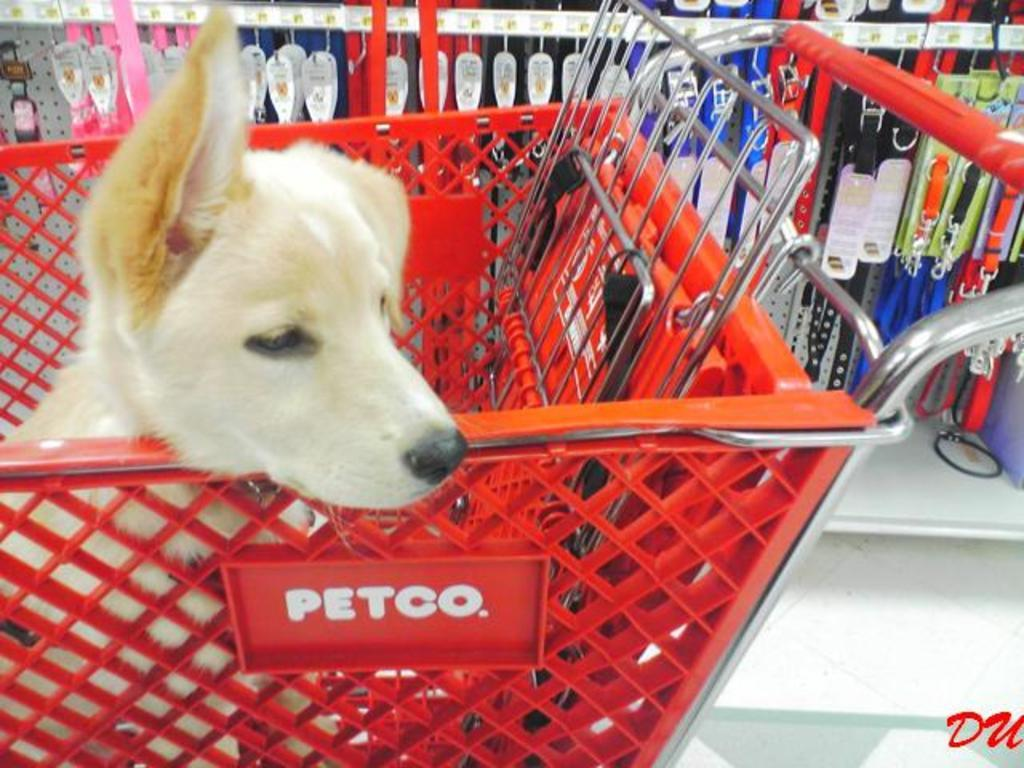What is in the trolley in the image? There is a dog in the trolley in the image. What is the appearance of the background in the image? The background resembles a store, with items hanging. Where is the text located in the image? The text is at the bottom right corner of the picture. Who is the owner of the vessel in the image? There is no vessel present in the image. Is there a bridge visible in the image? No, there is no bridge visible in the image. 